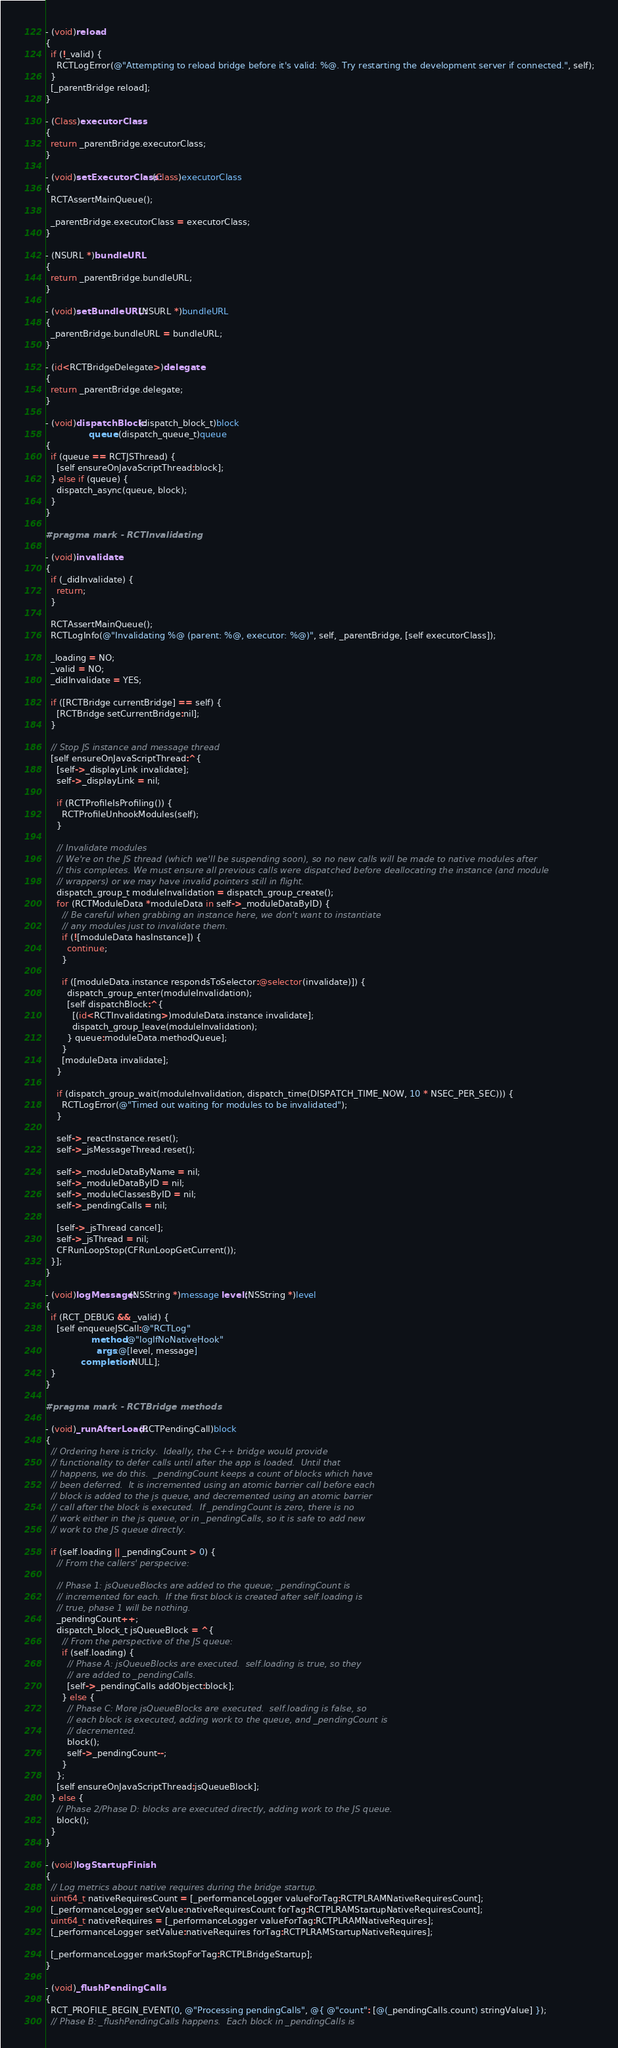<code> <loc_0><loc_0><loc_500><loc_500><_ObjectiveC_>- (void)reload
{
  if (!_valid) {
    RCTLogError(@"Attempting to reload bridge before it's valid: %@. Try restarting the development server if connected.", self);
  }
  [_parentBridge reload];
}

- (Class)executorClass
{
  return _parentBridge.executorClass;
}

- (void)setExecutorClass:(Class)executorClass
{
  RCTAssertMainQueue();

  _parentBridge.executorClass = executorClass;
}

- (NSURL *)bundleURL
{
  return _parentBridge.bundleURL;
}

- (void)setBundleURL:(NSURL *)bundleURL
{
  _parentBridge.bundleURL = bundleURL;
}

- (id<RCTBridgeDelegate>)delegate
{
  return _parentBridge.delegate;
}

- (void)dispatchBlock:(dispatch_block_t)block
                queue:(dispatch_queue_t)queue
{
  if (queue == RCTJSThread) {
    [self ensureOnJavaScriptThread:block];
  } else if (queue) {
    dispatch_async(queue, block);
  }
}

#pragma mark - RCTInvalidating

- (void)invalidate
{
  if (_didInvalidate) {
    return;
  }

  RCTAssertMainQueue();
  RCTLogInfo(@"Invalidating %@ (parent: %@, executor: %@)", self, _parentBridge, [self executorClass]);

  _loading = NO;
  _valid = NO;
  _didInvalidate = YES;

  if ([RCTBridge currentBridge] == self) {
    [RCTBridge setCurrentBridge:nil];
  }

  // Stop JS instance and message thread
  [self ensureOnJavaScriptThread:^{
    [self->_displayLink invalidate];
    self->_displayLink = nil;

    if (RCTProfileIsProfiling()) {
      RCTProfileUnhookModules(self);
    }

    // Invalidate modules
    // We're on the JS thread (which we'll be suspending soon), so no new calls will be made to native modules after
    // this completes. We must ensure all previous calls were dispatched before deallocating the instance (and module
    // wrappers) or we may have invalid pointers still in flight.
    dispatch_group_t moduleInvalidation = dispatch_group_create();
    for (RCTModuleData *moduleData in self->_moduleDataByID) {
      // Be careful when grabbing an instance here, we don't want to instantiate
      // any modules just to invalidate them.
      if (![moduleData hasInstance]) {
        continue;
      }

      if ([moduleData.instance respondsToSelector:@selector(invalidate)]) {
        dispatch_group_enter(moduleInvalidation);
        [self dispatchBlock:^{
          [(id<RCTInvalidating>)moduleData.instance invalidate];
          dispatch_group_leave(moduleInvalidation);
        } queue:moduleData.methodQueue];
      }
      [moduleData invalidate];
    }

    if (dispatch_group_wait(moduleInvalidation, dispatch_time(DISPATCH_TIME_NOW, 10 * NSEC_PER_SEC))) {
      RCTLogError(@"Timed out waiting for modules to be invalidated");
    }

    self->_reactInstance.reset();
    self->_jsMessageThread.reset();

    self->_moduleDataByName = nil;
    self->_moduleDataByID = nil;
    self->_moduleClassesByID = nil;
    self->_pendingCalls = nil;

    [self->_jsThread cancel];
    self->_jsThread = nil;
    CFRunLoopStop(CFRunLoopGetCurrent());
  }];
}

- (void)logMessage:(NSString *)message level:(NSString *)level
{
  if (RCT_DEBUG && _valid) {
    [self enqueueJSCall:@"RCTLog"
                 method:@"logIfNoNativeHook"
                   args:@[level, message]
             completion:NULL];
  }
}

#pragma mark - RCTBridge methods

- (void)_runAfterLoad:(RCTPendingCall)block
{
  // Ordering here is tricky.  Ideally, the C++ bridge would provide
  // functionality to defer calls until after the app is loaded.  Until that
  // happens, we do this.  _pendingCount keeps a count of blocks which have
  // been deferred.  It is incremented using an atomic barrier call before each
  // block is added to the js queue, and decremented using an atomic barrier
  // call after the block is executed.  If _pendingCount is zero, there is no
  // work either in the js queue, or in _pendingCalls, so it is safe to add new
  // work to the JS queue directly.

  if (self.loading || _pendingCount > 0) {
    // From the callers' perspecive:

    // Phase 1: jsQueueBlocks are added to the queue; _pendingCount is
    // incremented for each.  If the first block is created after self.loading is
    // true, phase 1 will be nothing.
    _pendingCount++;
    dispatch_block_t jsQueueBlock = ^{
      // From the perspective of the JS queue:
      if (self.loading) {
        // Phase A: jsQueueBlocks are executed.  self.loading is true, so they
        // are added to _pendingCalls.
        [self->_pendingCalls addObject:block];
      } else {
        // Phase C: More jsQueueBlocks are executed.  self.loading is false, so
        // each block is executed, adding work to the queue, and _pendingCount is
        // decremented.
        block();
        self->_pendingCount--;
      }
    };
    [self ensureOnJavaScriptThread:jsQueueBlock];
  } else {
    // Phase 2/Phase D: blocks are executed directly, adding work to the JS queue.
    block();
  }
}

- (void)logStartupFinish
{
  // Log metrics about native requires during the bridge startup.
  uint64_t nativeRequiresCount = [_performanceLogger valueForTag:RCTPLRAMNativeRequiresCount];
  [_performanceLogger setValue:nativeRequiresCount forTag:RCTPLRAMStartupNativeRequiresCount];
  uint64_t nativeRequires = [_performanceLogger valueForTag:RCTPLRAMNativeRequires];
  [_performanceLogger setValue:nativeRequires forTag:RCTPLRAMStartupNativeRequires];

  [_performanceLogger markStopForTag:RCTPLBridgeStartup];
}

- (void)_flushPendingCalls
{
  RCT_PROFILE_BEGIN_EVENT(0, @"Processing pendingCalls", @{ @"count": [@(_pendingCalls.count) stringValue] });
  // Phase B: _flushPendingCalls happens.  Each block in _pendingCalls is</code> 